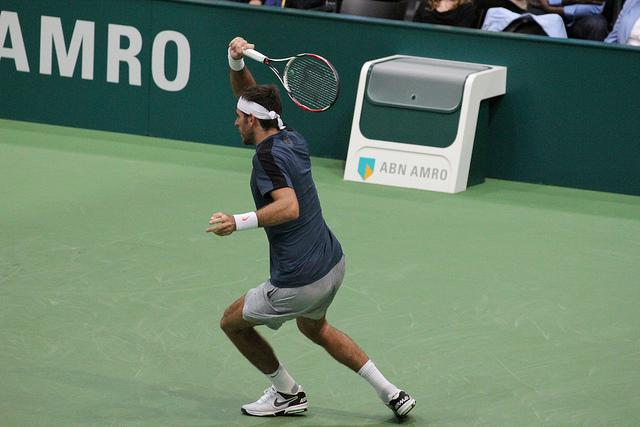What bank is a sponsor of the tennis event? abn amro 